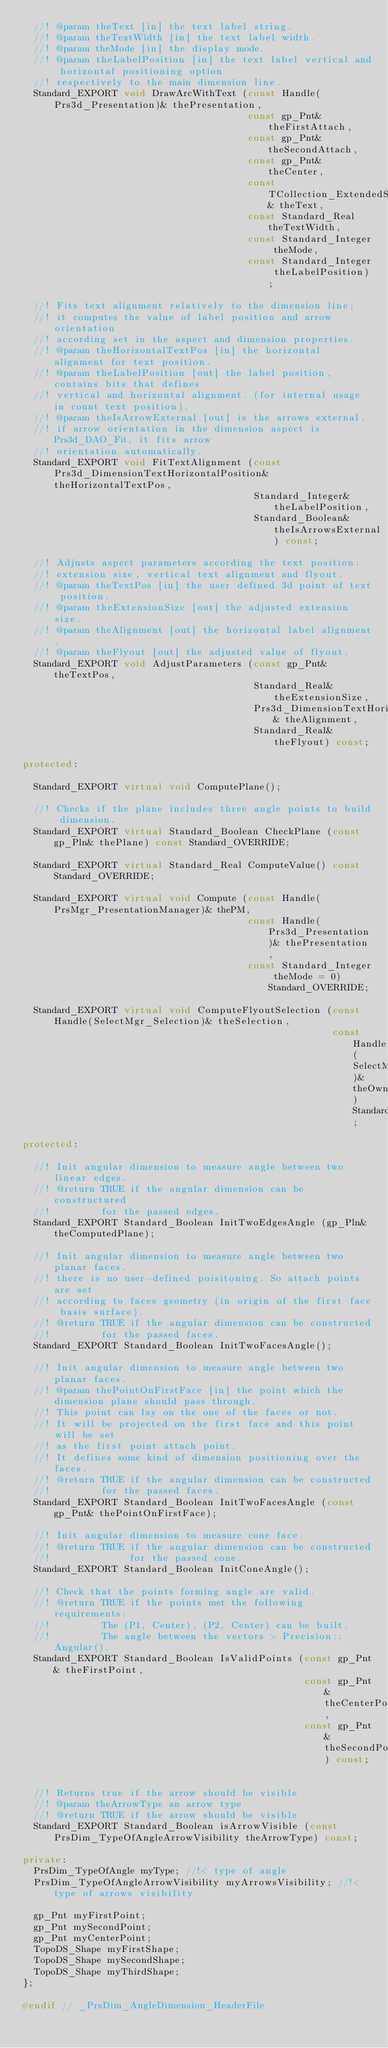Convert code to text. <code><loc_0><loc_0><loc_500><loc_500><_C++_>  //! @param theText [in] the text label string.
  //! @param theTextWidth [in] the text label width. 
  //! @param theMode [in] the display mode.
  //! @param theLabelPosition [in] the text label vertical and horizontal positioning option
  //! respectively to the main dimension line. 
  Standard_EXPORT void DrawArcWithText (const Handle(Prs3d_Presentation)& thePresentation,
                                        const gp_Pnt& theFirstAttach,
                                        const gp_Pnt& theSecondAttach,
                                        const gp_Pnt& theCenter,
                                        const TCollection_ExtendedString& theText,
                                        const Standard_Real theTextWidth,
                                        const Standard_Integer theMode,
                                        const Standard_Integer theLabelPosition);

  //! Fits text alignment relatively to the dimension line;
  //! it computes the value of label position and arrow orientation
  //! according set in the aspect and dimension properties.
  //! @param theHorizontalTextPos [in] the horizontal alignment for text position.
  //! @param theLabelPosition [out] the label position, contains bits that defines
  //! vertical and horizontal alignment. (for internal usage in count text position).
  //! @param theIsArrowExternal [out] is the arrows external,
  //! if arrow orientation in the dimension aspect is Prs3d_DAO_Fit, it fits arrow
  //! orientation automatically.
  Standard_EXPORT void FitTextAlignment (const Prs3d_DimensionTextHorizontalPosition& theHorizontalTextPos,
                                         Standard_Integer& theLabelPosition,
                                         Standard_Boolean& theIsArrowsExternal) const;

  //! Adjusts aspect parameters according the text position:
  //! extension size, vertical text alignment and flyout.
  //! @param theTextPos [in] the user defined 3d point of text position.
  //! @param theExtensionSize [out] the adjusted extension size.
  //! @param theAlignment [out] the horizontal label alignment.
  //! @param theFlyout [out] the adjusted value of flyout.
  Standard_EXPORT void AdjustParameters (const gp_Pnt& theTextPos,
                                         Standard_Real& theExtensionSize,
                                         Prs3d_DimensionTextHorizontalPosition& theAlignment,
                                         Standard_Real& theFlyout) const;

protected:

  Standard_EXPORT virtual void ComputePlane();

  //! Checks if the plane includes three angle points to build dimension.
  Standard_EXPORT virtual Standard_Boolean CheckPlane (const gp_Pln& thePlane) const Standard_OVERRIDE;

  Standard_EXPORT virtual Standard_Real ComputeValue() const Standard_OVERRIDE;

  Standard_EXPORT virtual void Compute (const Handle(PrsMgr_PresentationManager)& thePM,
                                        const Handle(Prs3d_Presentation)& thePresentation,
                                        const Standard_Integer theMode = 0) Standard_OVERRIDE;

  Standard_EXPORT virtual void ComputeFlyoutSelection (const Handle(SelectMgr_Selection)& theSelection,
                                                       const Handle(SelectMgr_EntityOwner)& theOwner) Standard_OVERRIDE;

protected:

  //! Init angular dimension to measure angle between two linear edges.
  //! @return TRUE if the angular dimension can be constructured
  //!         for the passed edges.
  Standard_EXPORT Standard_Boolean InitTwoEdgesAngle (gp_Pln& theComputedPlane);

  //! Init angular dimension to measure angle between two planar faces.
  //! there is no user-defined poisitoning. So attach points are set
  //! according to faces geometry (in origin of the first face basis surface).
  //! @return TRUE if the angular dimension can be constructed
  //!         for the passed faces.
  Standard_EXPORT Standard_Boolean InitTwoFacesAngle();

  //! Init angular dimension to measure angle between two planar faces.
  //! @param thePointOnFirstFace [in] the point which the dimension plane should pass through.
  //! This point can lay on the one of the faces or not.
  //! It will be projected on the first face and this point will be set
  //! as the first point attach point.
  //! It defines some kind of dimension positioning over the faces.
  //! @return TRUE if the angular dimension can be constructed
  //!         for the passed faces.
  Standard_EXPORT Standard_Boolean InitTwoFacesAngle (const gp_Pnt& thePointOnFirstFace);

  //! Init angular dimension to measure cone face.
  //! @return TRUE if the angular dimension can be constructed
  //!              for the passed cone.
  Standard_EXPORT Standard_Boolean InitConeAngle();

  //! Check that the points forming angle are valid.
  //! @return TRUE if the points met the following requirements:
  //!         The (P1, Center), (P2, Center) can be built.
  //!         The angle between the vectors > Precision::Angular().
  Standard_EXPORT Standard_Boolean IsValidPoints (const gp_Pnt& theFirstPoint,
                                                  const gp_Pnt& theCenterPoint,
                                                  const gp_Pnt& theSecondPoint) const;


  //! Returns true if the arrow should be visible
  //! @param theArrowType an arrow type
  //! @return TRUE if the arrow should be visible
  Standard_EXPORT Standard_Boolean isArrowVisible (const PrsDim_TypeOfAngleArrowVisibility theArrowType) const;

private:
  PrsDim_TypeOfAngle myType; //!< type of angle
  PrsDim_TypeOfAngleArrowVisibility myArrowsVisibility; //!< type of arrows visibility

  gp_Pnt myFirstPoint;
  gp_Pnt mySecondPoint;
  gp_Pnt myCenterPoint;
  TopoDS_Shape myFirstShape;
  TopoDS_Shape mySecondShape;
  TopoDS_Shape myThirdShape;
};

#endif // _PrsDim_AngleDimension_HeaderFile
</code> 